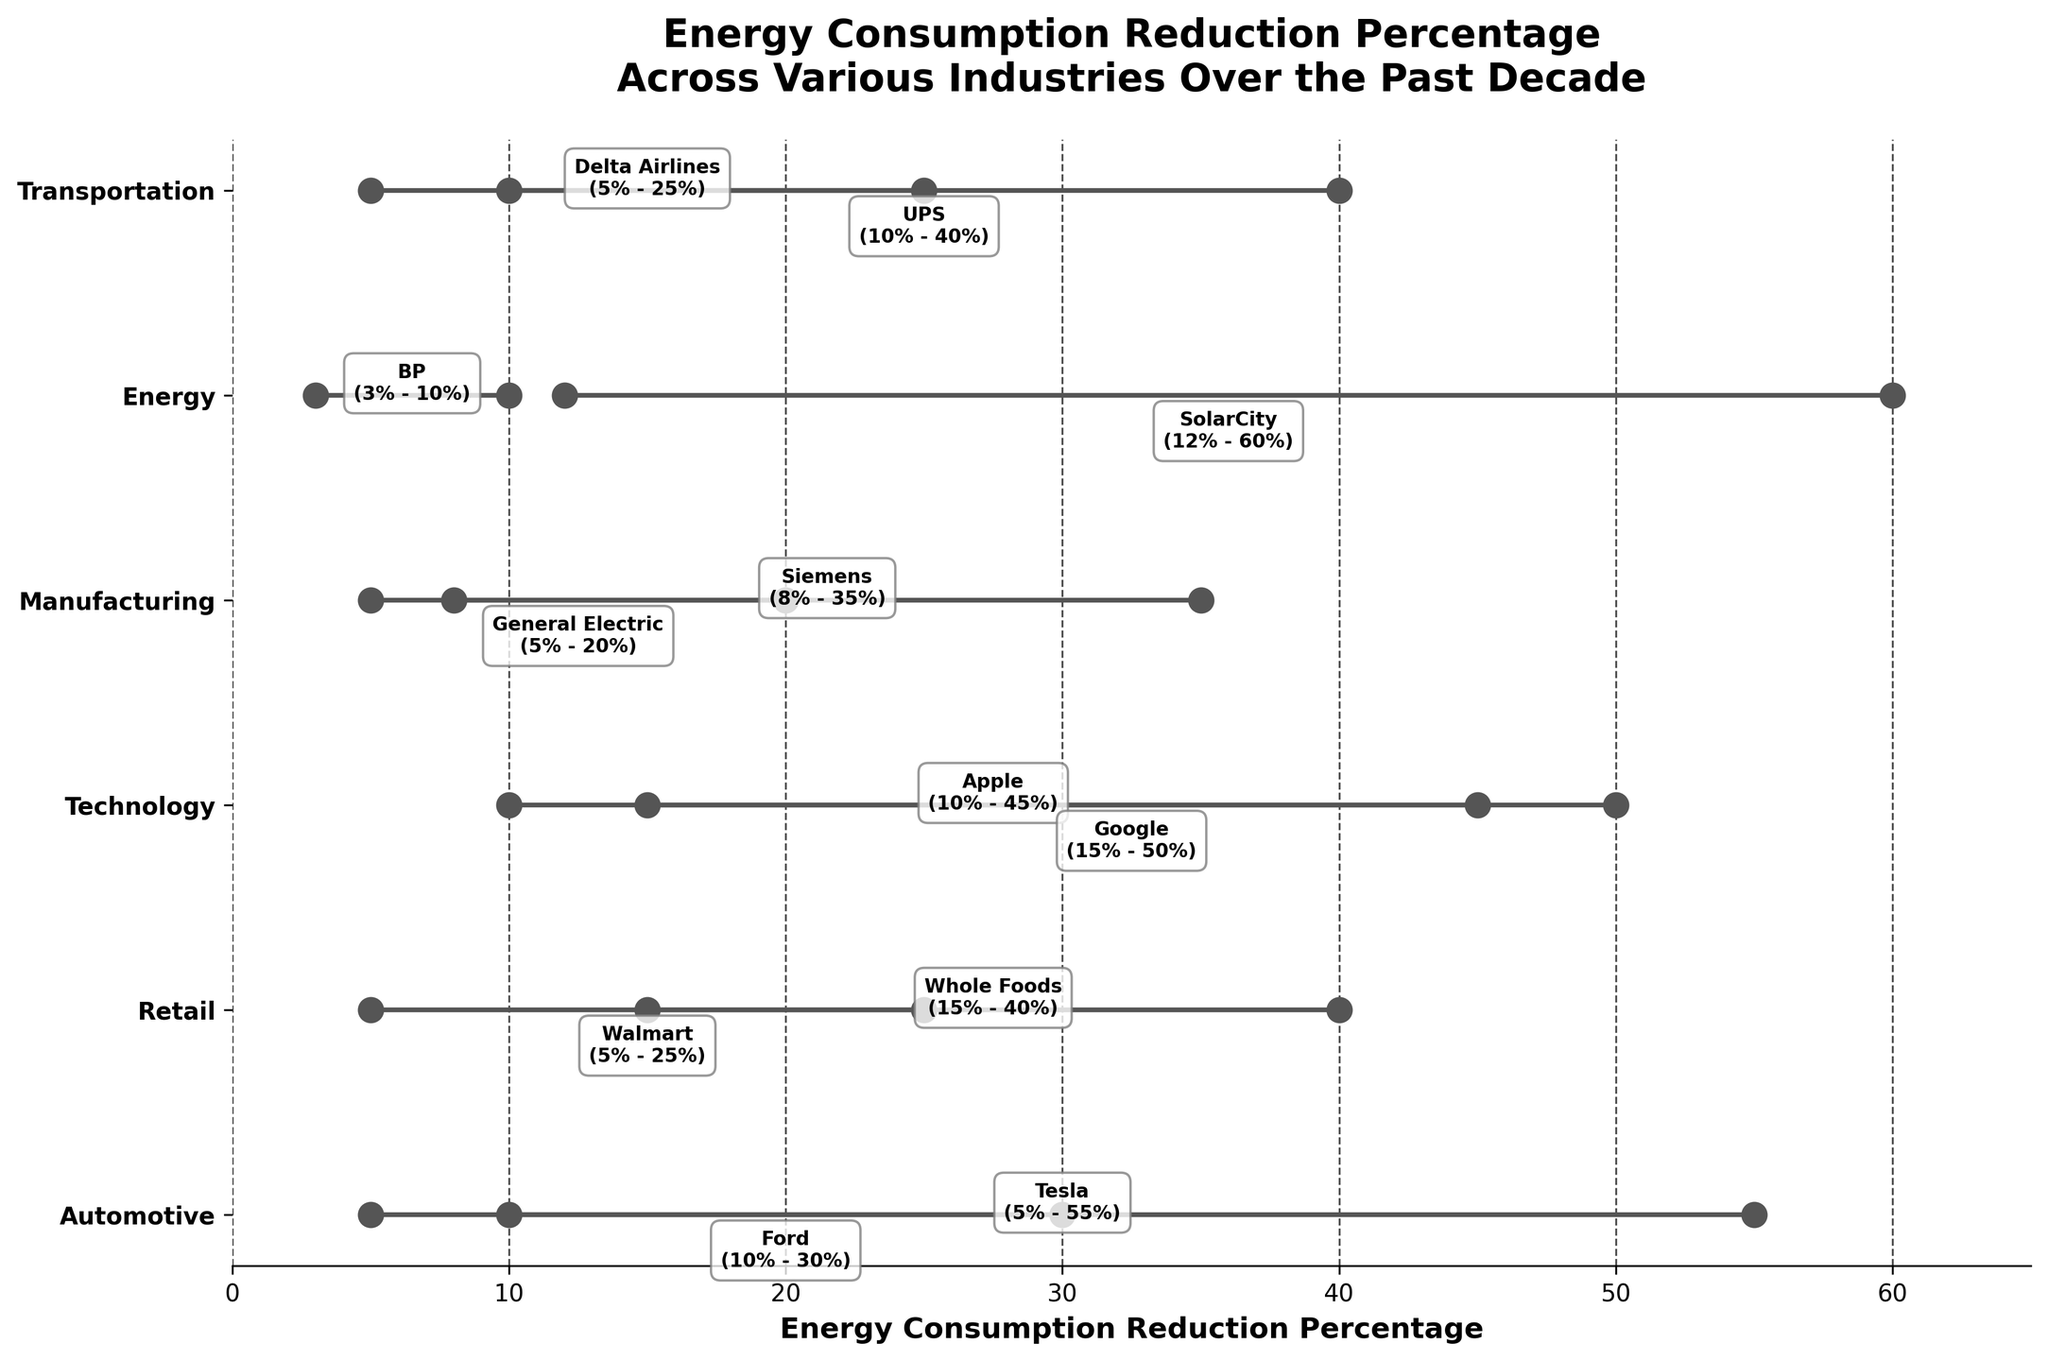How many industries are represented in the figure? Count the number of unique industry labels on the y-axis. There are six unique labels: Automotive, Retail, Technology, Manufacturing, Energy, and Transportation.
Answer: 6 What is the energy consumption reduction percentage of Google? Look at the labels and lines associated with the Technology industry, find the annotated company Google. The start percentage is 15% and the end percentage is 50%.
Answer: 15% - 50% Which industry has the highest end percentage reduction and what is it? Scan through the endpoints of all the lines. The highest point is at 60%, which corresponds to the company SolarCity in the Energy industry.
Answer: Energy, 60% What is the difference in energy reduction percentages between Tesla and Ford? Find Tesla and Ford in the Automotive industry. Tesla's end percentage is 55% and start is 5%, so the reduction is 55% - 5% = 50%. Ford's end percentage is 30% and start is 10%, so the reduction is 30% - 10% = 20%. The difference is 50% - 20% = 30%.
Answer: 30% Which company in the Retail industry saw the biggest reduction in energy consumption? Locate the Retail industry and compare the reductions for Whole Foods and Walmart. Whole Foods reduced from 15% to 40% (25% reduction), while Walmart reduced from 5% to 25% (20% reduction). The largest reduction is 25% by Whole Foods.
Answer: Whole Foods What is the average start percentage in the Technology industry? Add the starting percentages for Apple (10%) and Google (15%), then divide by the number of companies (2). (10% + 15%) / 2 = 12.5%.
Answer: 12.5% Which industry shows the smallest difference in reduction from the start to end percentages overall? Calculate the difference for each industry by looking at each company's data and averaging it, then find the smallest. For Energy: BP (7%) and SolarCity (48%) average to 27.5%. Continue similarly for other industries, and compare the averages.
Answer: Energy, 27.5% What is the total range of reduction percentages for the Manufacturing industry? Find Siemens and General Electric in the Manufacturing industry. Their ranges are 8%-35% and 5%-20% respectively. The overall range is from the smallest start (5%) to the largest end (35%). So, the total range is 35% - 5% = 30%.
Answer: 30% Which transportation company achieved a higher reduction in energy consumption, Delta Airlines or UPS? Look at Delta Airlines and UPS in the Transportation industry. Delta Airlines reduced from 5% to 25% (20% reduction) and UPS from 10% to 40% (30% reduction). The higher reduction is by UPS with 30%.
Answer: UPS What is the median endpoint percentage for the companies in the plot? Collect all end percentages (10, 20, 25, 25, 30, 35, 40, 40, 45, 50, 55, 60), sort them, and find the median. The sorted list is {10, 20, 25, 25, 30, 35, 40, 40, 45, 50, 55, 60}. Since there are 12 values, the median is the average of the 6th and 7th values, (35 + 40) / 2 = 37.5%.
Answer: 37.5% 